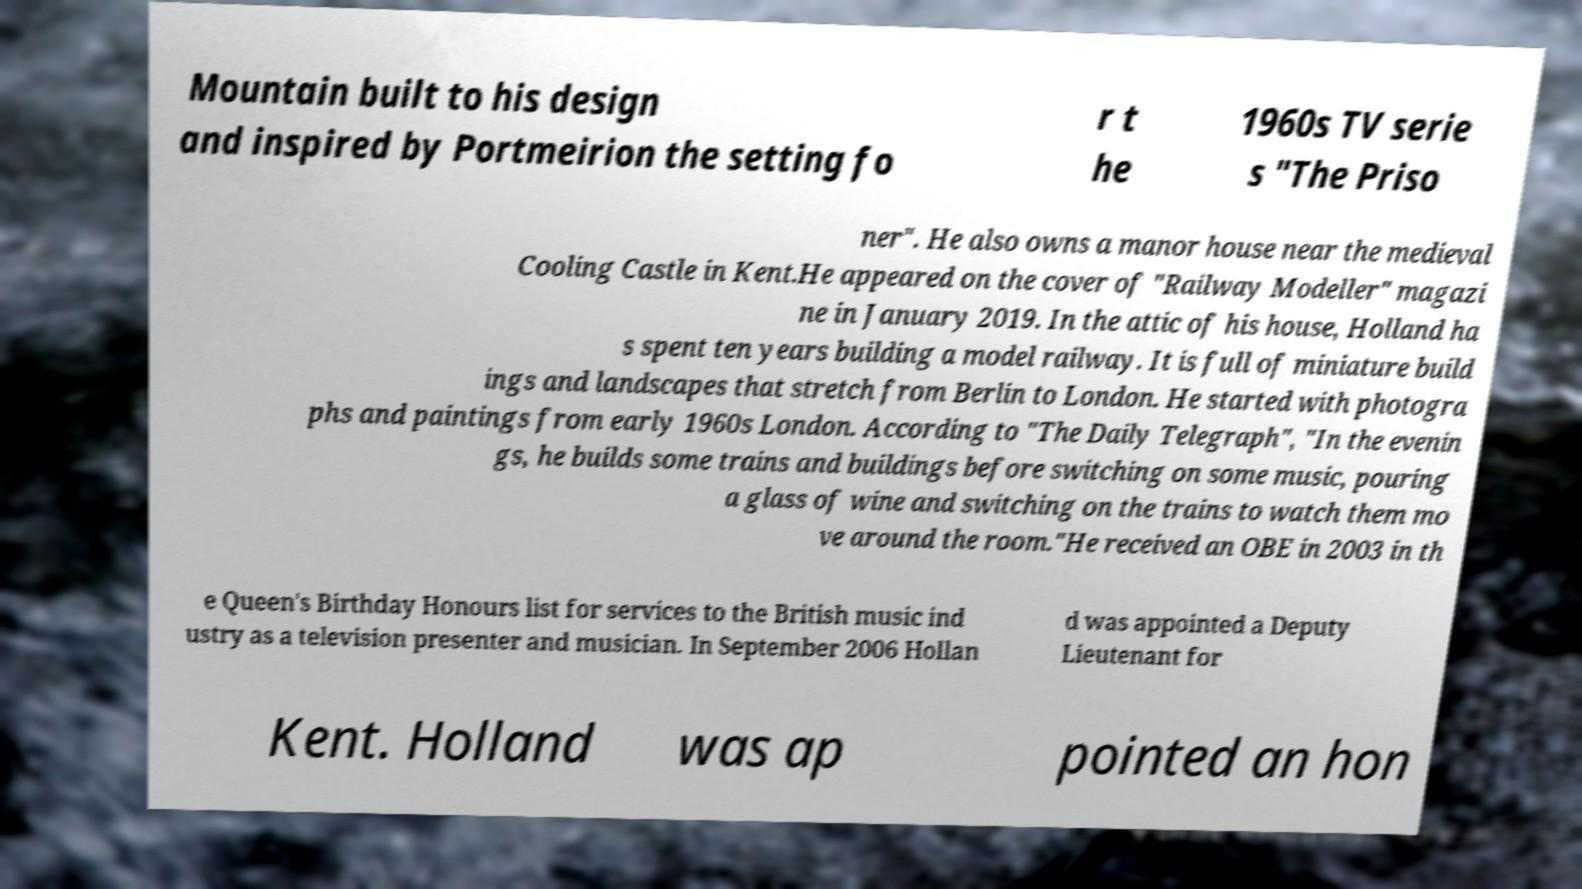Could you assist in decoding the text presented in this image and type it out clearly? Mountain built to his design and inspired by Portmeirion the setting fo r t he 1960s TV serie s "The Priso ner". He also owns a manor house near the medieval Cooling Castle in Kent.He appeared on the cover of "Railway Modeller" magazi ne in January 2019. In the attic of his house, Holland ha s spent ten years building a model railway. It is full of miniature build ings and landscapes that stretch from Berlin to London. He started with photogra phs and paintings from early 1960s London. According to "The Daily Telegraph", "In the evenin gs, he builds some trains and buildings before switching on some music, pouring a glass of wine and switching on the trains to watch them mo ve around the room."He received an OBE in 2003 in th e Queen's Birthday Honours list for services to the British music ind ustry as a television presenter and musician. In September 2006 Hollan d was appointed a Deputy Lieutenant for Kent. Holland was ap pointed an hon 